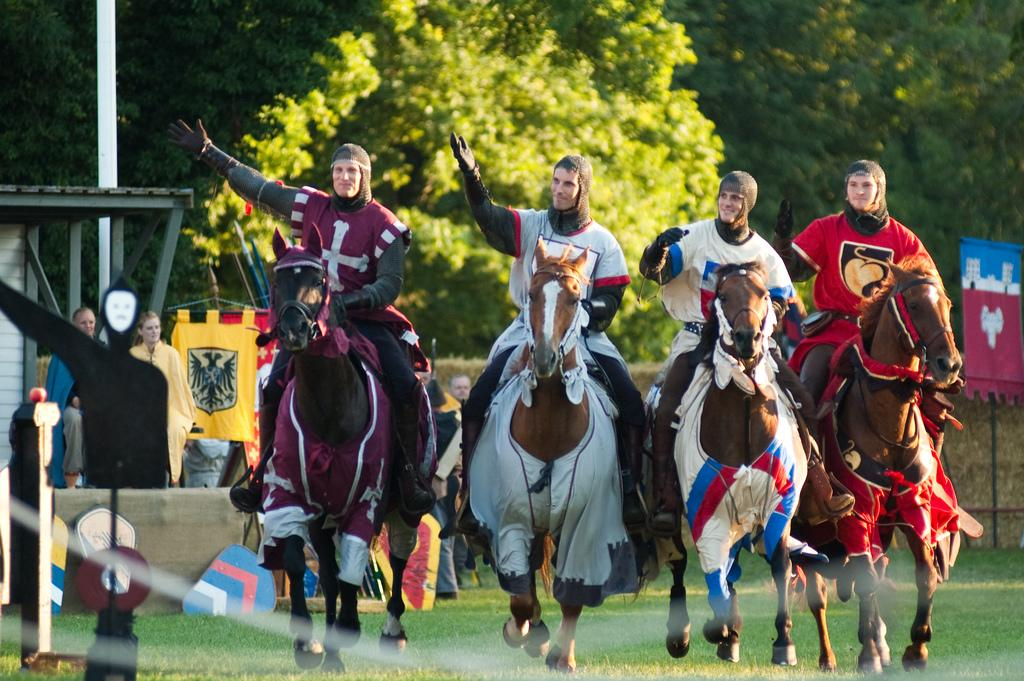What type of natural elements can be seen in the image? There are trees in the image. What additional object is present in the image? There is a banner in the image. Are there any human subjects in the image? Yes, there are people present in the image. How many people are riding horses in the image? Four people are sitting on horses in the image. What type of authority figure can be seen in the image? There is no authority figure present in the image. How many managers are visible in the image? There is no mention of managers in the image. 